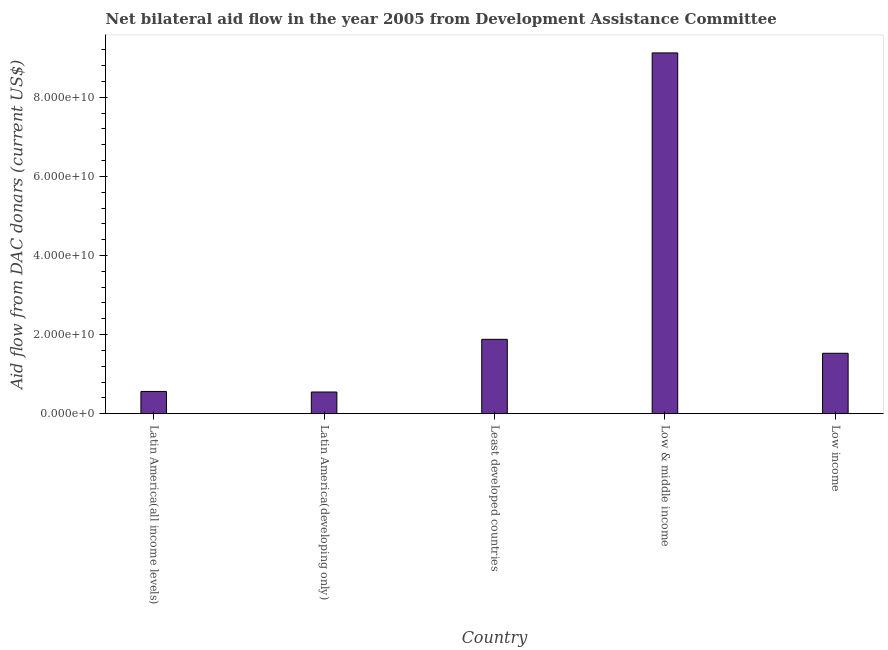Does the graph contain any zero values?
Provide a short and direct response. No. Does the graph contain grids?
Provide a succinct answer. No. What is the title of the graph?
Your answer should be compact. Net bilateral aid flow in the year 2005 from Development Assistance Committee. What is the label or title of the Y-axis?
Keep it short and to the point. Aid flow from DAC donars (current US$). What is the net bilateral aid flows from dac donors in Low & middle income?
Offer a very short reply. 9.12e+1. Across all countries, what is the maximum net bilateral aid flows from dac donors?
Make the answer very short. 9.12e+1. Across all countries, what is the minimum net bilateral aid flows from dac donors?
Provide a succinct answer. 5.49e+09. In which country was the net bilateral aid flows from dac donors minimum?
Offer a terse response. Latin America(developing only). What is the sum of the net bilateral aid flows from dac donors?
Offer a terse response. 1.36e+11. What is the difference between the net bilateral aid flows from dac donors in Latin America(all income levels) and Latin America(developing only)?
Your response must be concise. 1.41e+08. What is the average net bilateral aid flows from dac donors per country?
Ensure brevity in your answer.  2.73e+1. What is the median net bilateral aid flows from dac donors?
Provide a short and direct response. 1.53e+1. In how many countries, is the net bilateral aid flows from dac donors greater than 84000000000 US$?
Make the answer very short. 1. What is the ratio of the net bilateral aid flows from dac donors in Least developed countries to that in Low & middle income?
Offer a terse response. 0.21. Is the net bilateral aid flows from dac donors in Low & middle income less than that in Low income?
Keep it short and to the point. No. What is the difference between the highest and the second highest net bilateral aid flows from dac donors?
Provide a short and direct response. 7.24e+1. What is the difference between the highest and the lowest net bilateral aid flows from dac donors?
Your answer should be compact. 8.57e+1. In how many countries, is the net bilateral aid flows from dac donors greater than the average net bilateral aid flows from dac donors taken over all countries?
Ensure brevity in your answer.  1. How many bars are there?
Offer a very short reply. 5. Are all the bars in the graph horizontal?
Provide a succinct answer. No. What is the difference between two consecutive major ticks on the Y-axis?
Your answer should be very brief. 2.00e+1. Are the values on the major ticks of Y-axis written in scientific E-notation?
Your response must be concise. Yes. What is the Aid flow from DAC donars (current US$) in Latin America(all income levels)?
Give a very brief answer. 5.63e+09. What is the Aid flow from DAC donars (current US$) of Latin America(developing only)?
Your answer should be compact. 5.49e+09. What is the Aid flow from DAC donars (current US$) in Least developed countries?
Give a very brief answer. 1.88e+1. What is the Aid flow from DAC donars (current US$) in Low & middle income?
Keep it short and to the point. 9.12e+1. What is the Aid flow from DAC donars (current US$) in Low income?
Ensure brevity in your answer.  1.53e+1. What is the difference between the Aid flow from DAC donars (current US$) in Latin America(all income levels) and Latin America(developing only)?
Your answer should be compact. 1.41e+08. What is the difference between the Aid flow from DAC donars (current US$) in Latin America(all income levels) and Least developed countries?
Provide a succinct answer. -1.32e+1. What is the difference between the Aid flow from DAC donars (current US$) in Latin America(all income levels) and Low & middle income?
Your answer should be compact. -8.56e+1. What is the difference between the Aid flow from DAC donars (current US$) in Latin America(all income levels) and Low income?
Your answer should be very brief. -9.65e+09. What is the difference between the Aid flow from DAC donars (current US$) in Latin America(developing only) and Least developed countries?
Your response must be concise. -1.33e+1. What is the difference between the Aid flow from DAC donars (current US$) in Latin America(developing only) and Low & middle income?
Your answer should be compact. -8.57e+1. What is the difference between the Aid flow from DAC donars (current US$) in Latin America(developing only) and Low income?
Make the answer very short. -9.79e+09. What is the difference between the Aid flow from DAC donars (current US$) in Least developed countries and Low & middle income?
Ensure brevity in your answer.  -7.24e+1. What is the difference between the Aid flow from DAC donars (current US$) in Least developed countries and Low income?
Provide a succinct answer. 3.52e+09. What is the difference between the Aid flow from DAC donars (current US$) in Low & middle income and Low income?
Offer a very short reply. 7.59e+1. What is the ratio of the Aid flow from DAC donars (current US$) in Latin America(all income levels) to that in Latin America(developing only)?
Provide a succinct answer. 1.03. What is the ratio of the Aid flow from DAC donars (current US$) in Latin America(all income levels) to that in Least developed countries?
Offer a terse response. 0.3. What is the ratio of the Aid flow from DAC donars (current US$) in Latin America(all income levels) to that in Low & middle income?
Make the answer very short. 0.06. What is the ratio of the Aid flow from DAC donars (current US$) in Latin America(all income levels) to that in Low income?
Offer a very short reply. 0.37. What is the ratio of the Aid flow from DAC donars (current US$) in Latin America(developing only) to that in Least developed countries?
Ensure brevity in your answer.  0.29. What is the ratio of the Aid flow from DAC donars (current US$) in Latin America(developing only) to that in Low & middle income?
Offer a very short reply. 0.06. What is the ratio of the Aid flow from DAC donars (current US$) in Latin America(developing only) to that in Low income?
Keep it short and to the point. 0.36. What is the ratio of the Aid flow from DAC donars (current US$) in Least developed countries to that in Low & middle income?
Provide a short and direct response. 0.21. What is the ratio of the Aid flow from DAC donars (current US$) in Least developed countries to that in Low income?
Ensure brevity in your answer.  1.23. What is the ratio of the Aid flow from DAC donars (current US$) in Low & middle income to that in Low income?
Your response must be concise. 5.97. 